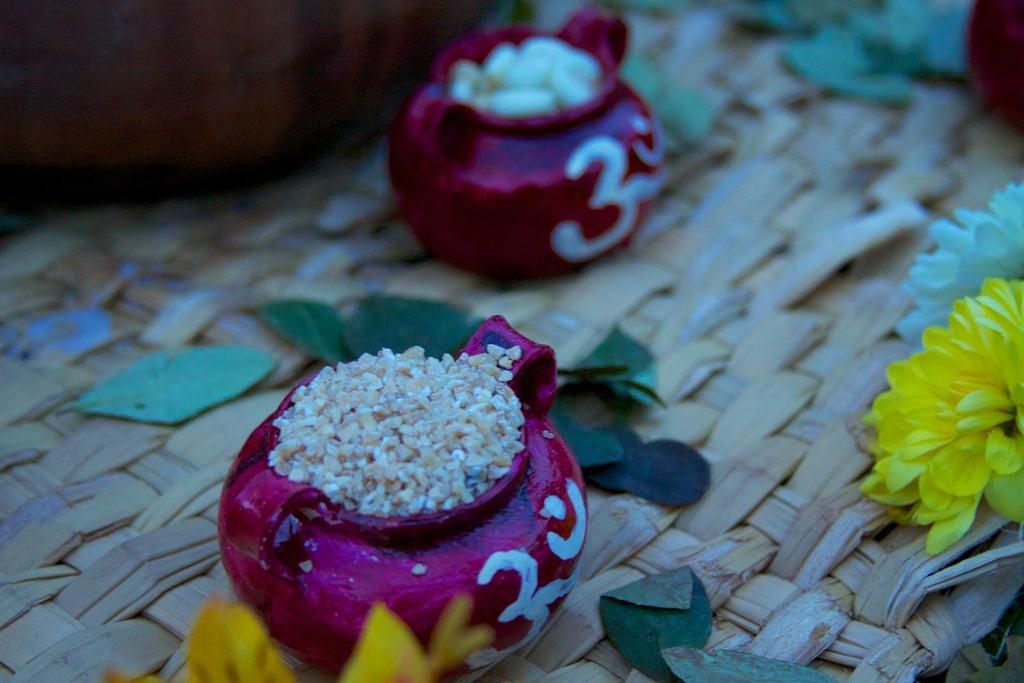Please provide a concise description of this image. In this image there are two colorful pots, in which there are some objects, kept on wooden mat, there are leaves, flowers on it. 